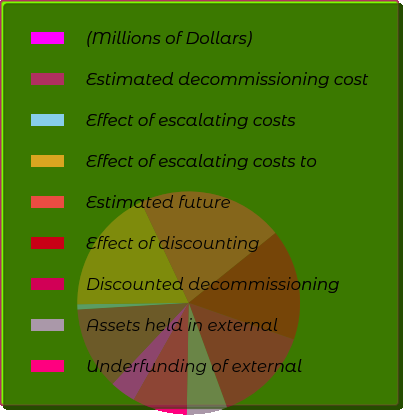<chart> <loc_0><loc_0><loc_500><loc_500><pie_chart><fcel>(Millions of Dollars)<fcel>Estimated decommissioning cost<fcel>Effect of escalating costs<fcel>Effect of escalating costs to<fcel>Estimated future<fcel>Effect of discounting<fcel>Discounted decommissioning<fcel>Assets held in external<fcel>Underfunding of external<nl><fcel>3.82%<fcel>12.02%<fcel>0.75%<fcel>18.17%<fcel>21.24%<fcel>16.12%<fcel>14.07%<fcel>5.87%<fcel>7.92%<nl></chart> 